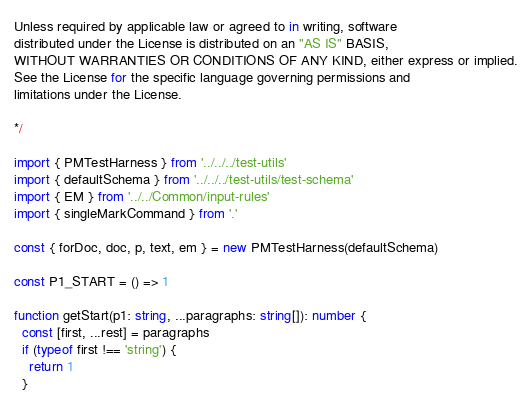Convert code to text. <code><loc_0><loc_0><loc_500><loc_500><_TypeScript_>Unless required by applicable law or agreed to in writing, software
distributed under the License is distributed on an "AS IS" BASIS,
WITHOUT WARRANTIES OR CONDITIONS OF ANY KIND, either express or implied.
See the License for the specific language governing permissions and
limitations under the License.

*/

import { PMTestHarness } from '../../../test-utils'
import { defaultSchema } from '../../../test-utils/test-schema'
import { EM } from '../../Common/input-rules'
import { singleMarkCommand } from '.'

const { forDoc, doc, p, text, em } = new PMTestHarness(defaultSchema)

const P1_START = () => 1

function getStart(p1: string, ...paragraphs: string[]): number {
  const [first, ...rest] = paragraphs
  if (typeof first !== 'string') {
    return 1
  }
</code> 